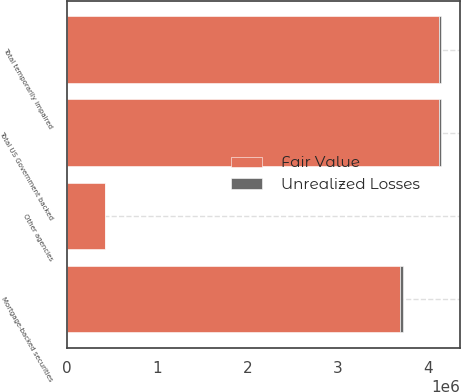Convert chart. <chart><loc_0><loc_0><loc_500><loc_500><stacked_bar_chart><ecel><fcel>Mortgage-backed securities<fcel>Other agencies<fcel>Total US Government backed<fcel>Total temporarily impaired<nl><fcel>Fair Value<fcel>3.69289e+06<fcel>425410<fcel>4.1183e+06<fcel>4.1183e+06<nl><fcel>Unrealized Losses<fcel>25418<fcel>2689<fcel>28107<fcel>28107<nl></chart> 